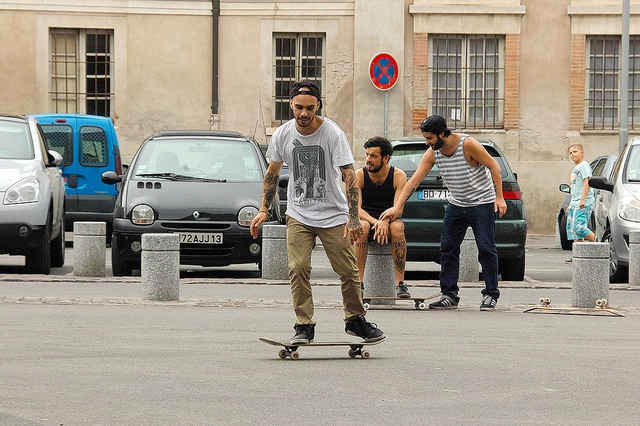Describe the objects in this image and their specific colors. I can see car in beige, black, darkgray, lightgray, and gray tones, people in beige, darkgray, gray, and black tones, people in beige, black, gray, and darkgray tones, car in beige, lightgray, black, darkgray, and gray tones, and car in beige, black, gray, darkgray, and lightgray tones in this image. 